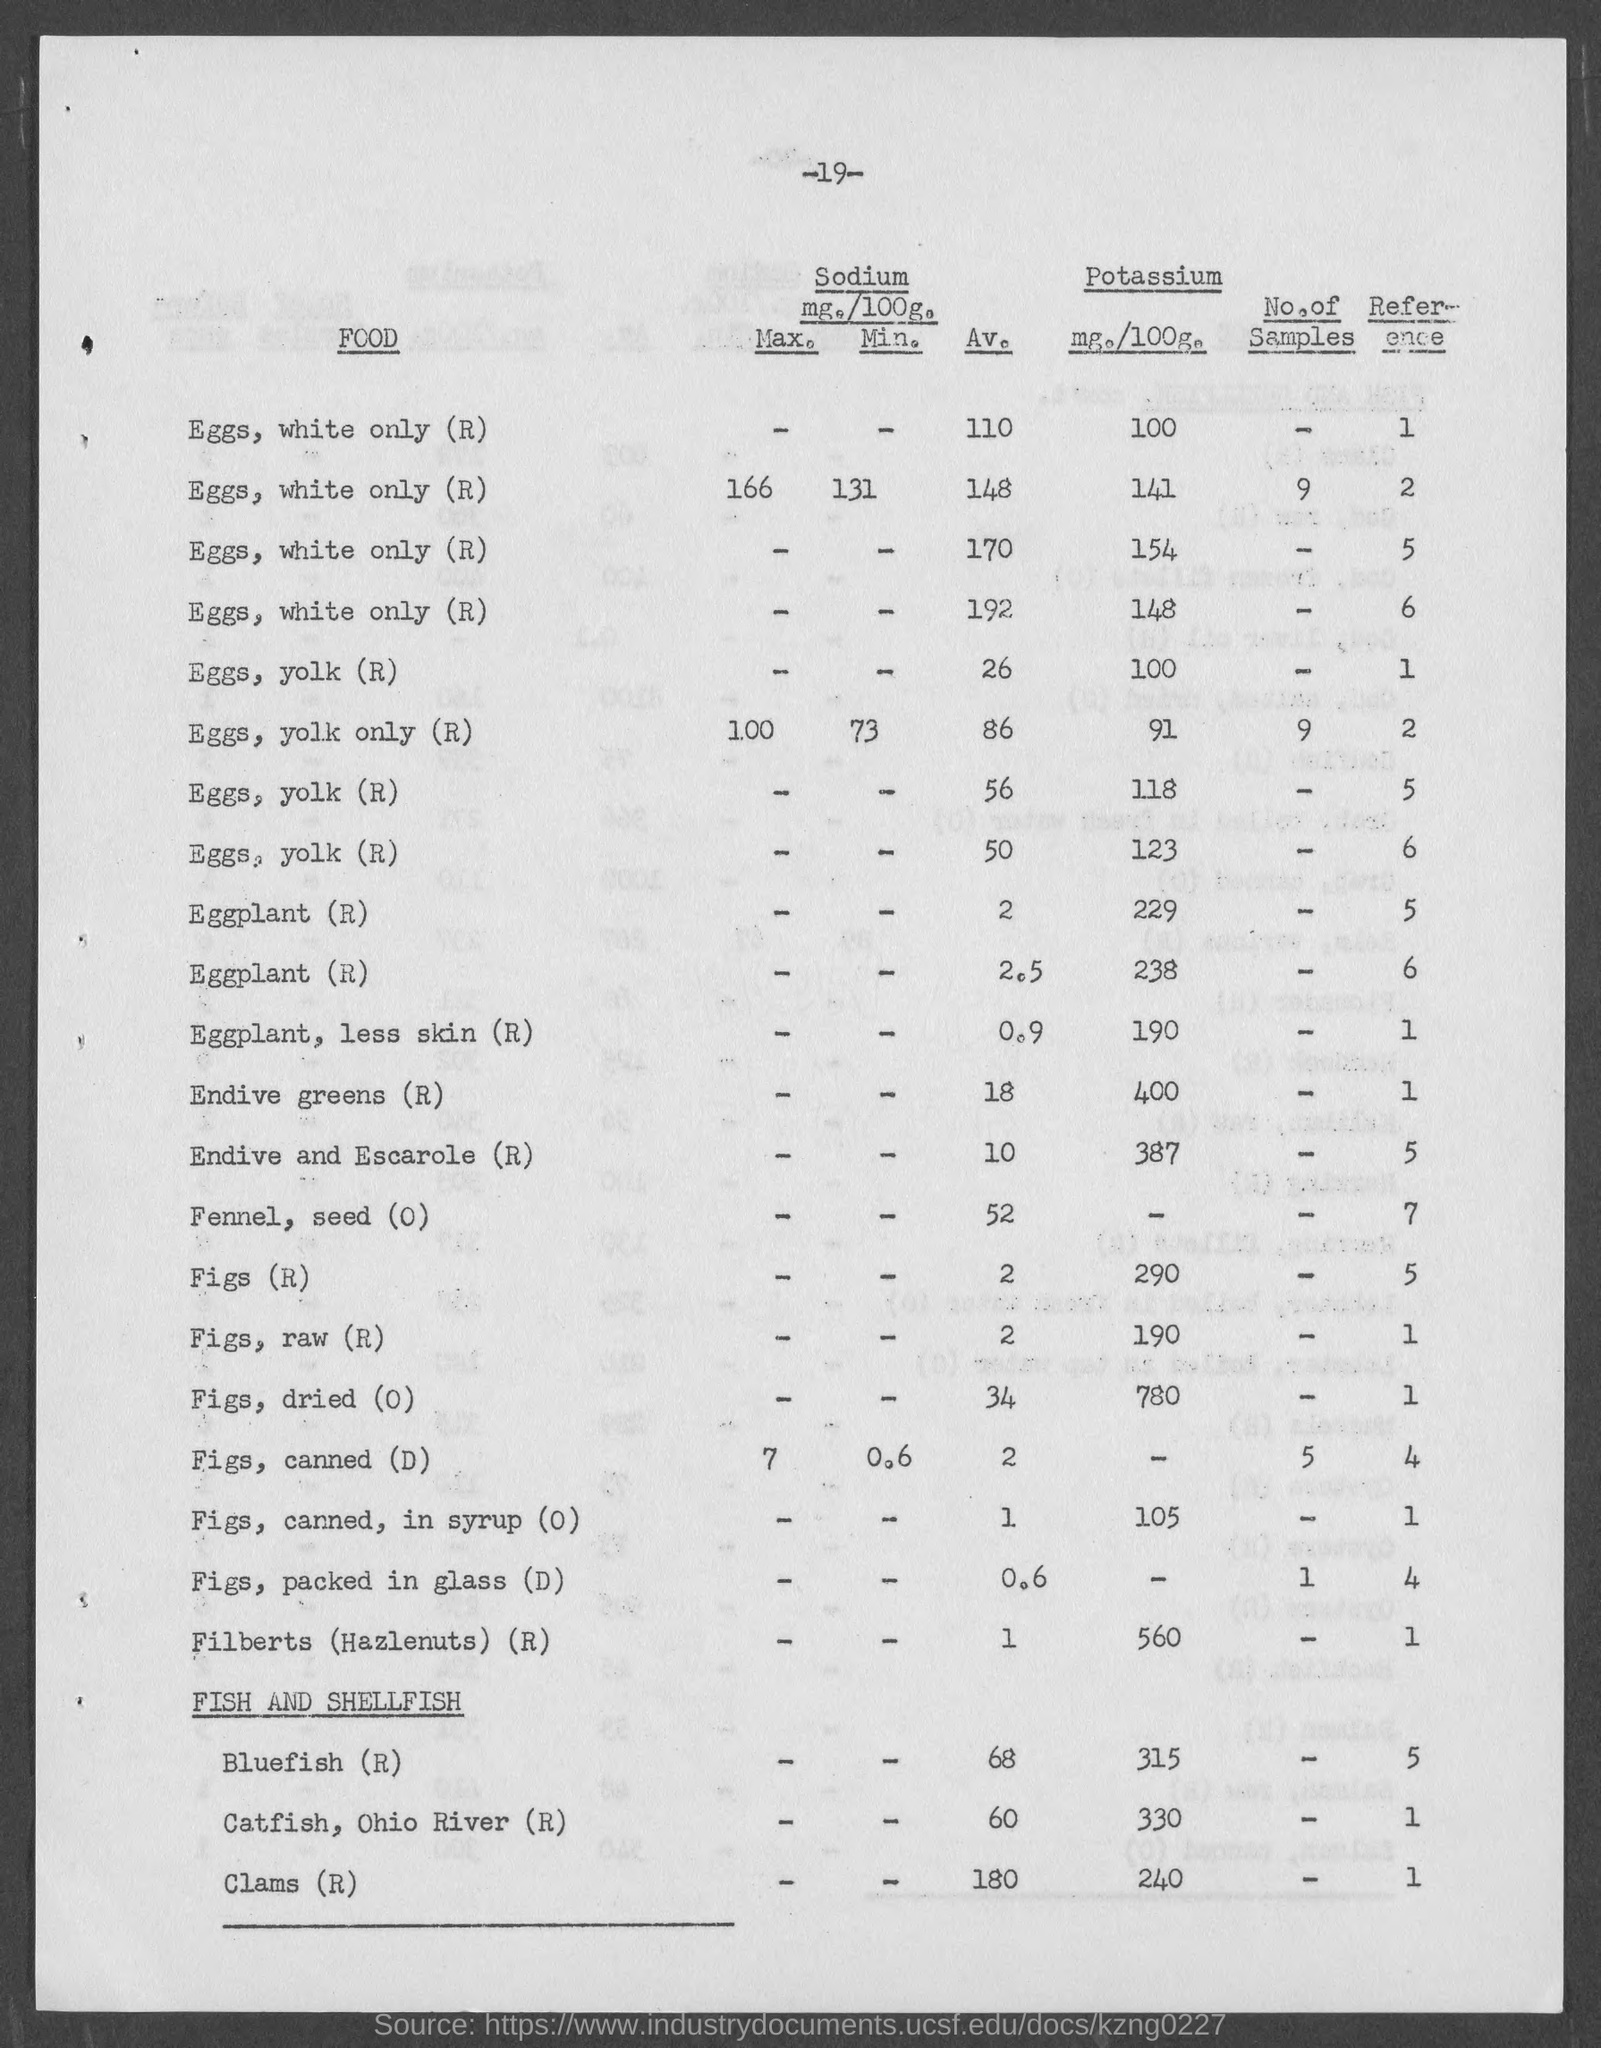What is the number at top of the page ?
Offer a terse response. -19-. What is amount of potassium mg./100g. of eggs, yolk only (r)?
Your answer should be compact. 91. What is amount of potassium mg./100g. of eggplant, less skin (r)?
Keep it short and to the point. 190. What is amount of potassium mg./100g. of endive greens (r)?
Offer a terse response. 400. What is amount of potassium mg./100g. of endive and escarole (r) ?
Ensure brevity in your answer.  387. What is amount of potassium mg./100g. of figs (r)?
Provide a short and direct response. 290. What is amount of potassium mg./100g. of figs, raw (r)?
Provide a short and direct response. 190. What is amount of potassium mg./100g. of figs, dried (o)?
Ensure brevity in your answer.  780. What is amount of potassium mg./100g. of figs, canned, in syrup (o)?
Your response must be concise. 105. What is amount of potassium mg./100g. of filberts ( hazlenuts ) (r)?
Provide a succinct answer. 560. 